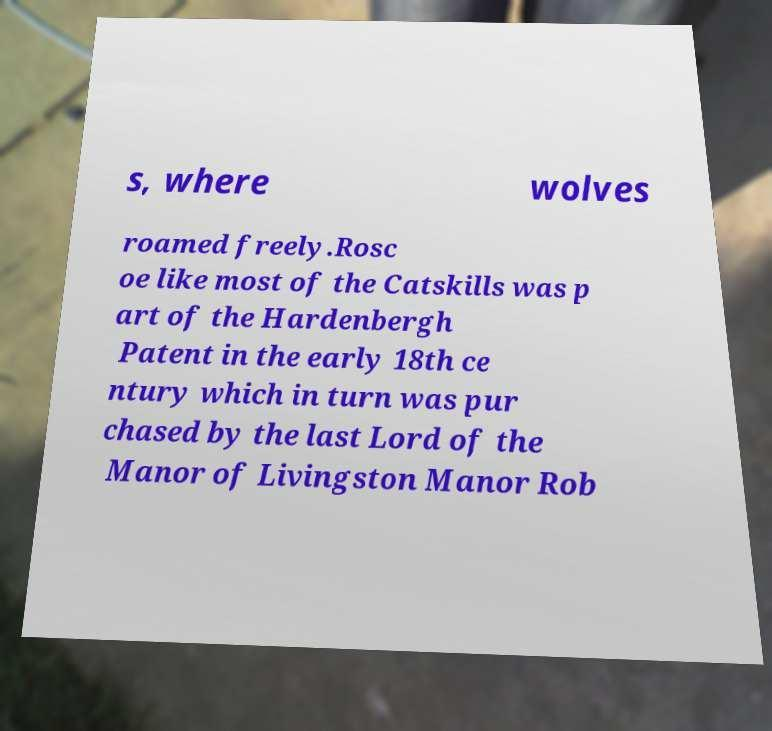For documentation purposes, I need the text within this image transcribed. Could you provide that? s, where wolves roamed freely.Rosc oe like most of the Catskills was p art of the Hardenbergh Patent in the early 18th ce ntury which in turn was pur chased by the last Lord of the Manor of Livingston Manor Rob 